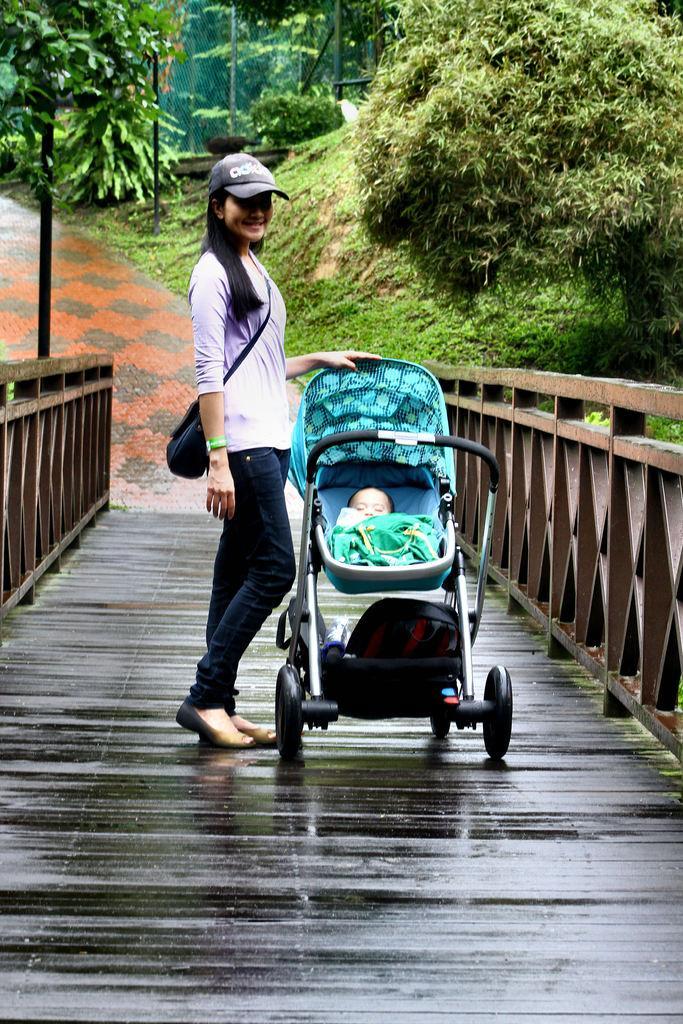In one or two sentences, can you explain what this image depicts? In this image we can see a baby in a carrier and a woman standing on the deck. We can also see the wooden fence, grass, the pathway, some poles and a group of trees. 